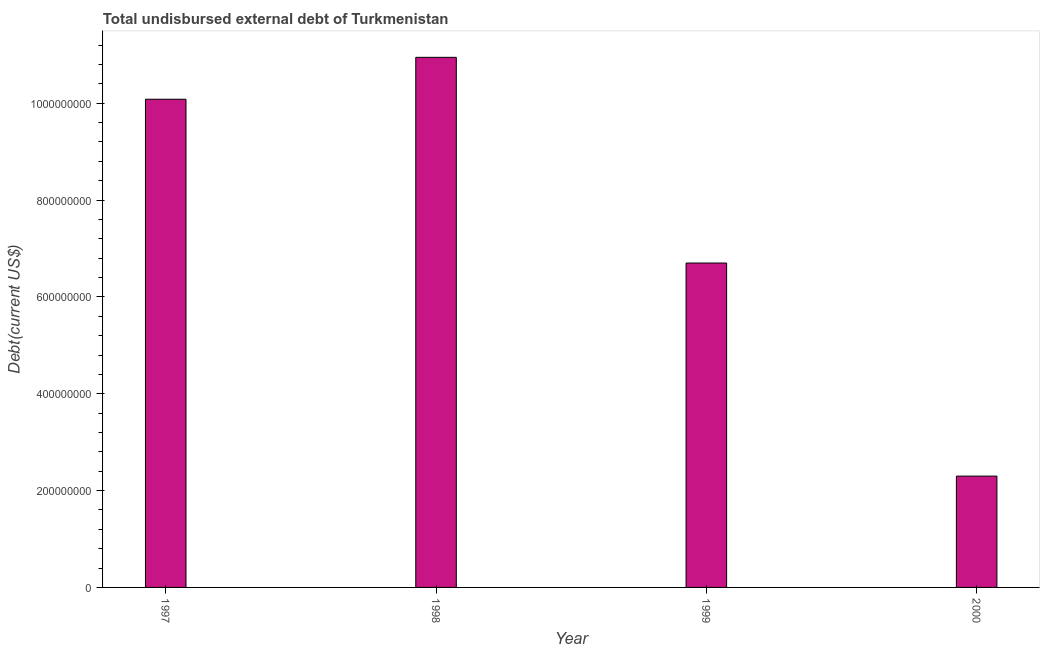What is the title of the graph?
Your response must be concise. Total undisbursed external debt of Turkmenistan. What is the label or title of the Y-axis?
Provide a short and direct response. Debt(current US$). What is the total debt in 1999?
Offer a very short reply. 6.70e+08. Across all years, what is the maximum total debt?
Provide a short and direct response. 1.09e+09. Across all years, what is the minimum total debt?
Make the answer very short. 2.30e+08. In which year was the total debt minimum?
Offer a terse response. 2000. What is the sum of the total debt?
Ensure brevity in your answer.  3.00e+09. What is the difference between the total debt in 1997 and 1999?
Provide a short and direct response. 3.38e+08. What is the average total debt per year?
Provide a short and direct response. 7.51e+08. What is the median total debt?
Your answer should be compact. 8.39e+08. In how many years, is the total debt greater than 680000000 US$?
Your response must be concise. 2. What is the ratio of the total debt in 1998 to that in 1999?
Provide a succinct answer. 1.63. Is the total debt in 1999 less than that in 2000?
Keep it short and to the point. No. Is the difference between the total debt in 1997 and 1998 greater than the difference between any two years?
Provide a short and direct response. No. What is the difference between the highest and the second highest total debt?
Ensure brevity in your answer.  8.66e+07. What is the difference between the highest and the lowest total debt?
Your response must be concise. 8.65e+08. In how many years, is the total debt greater than the average total debt taken over all years?
Offer a terse response. 2. How many bars are there?
Your answer should be very brief. 4. Are all the bars in the graph horizontal?
Keep it short and to the point. No. What is the difference between two consecutive major ticks on the Y-axis?
Give a very brief answer. 2.00e+08. What is the Debt(current US$) of 1997?
Keep it short and to the point. 1.01e+09. What is the Debt(current US$) of 1998?
Ensure brevity in your answer.  1.09e+09. What is the Debt(current US$) of 1999?
Offer a terse response. 6.70e+08. What is the Debt(current US$) in 2000?
Make the answer very short. 2.30e+08. What is the difference between the Debt(current US$) in 1997 and 1998?
Provide a short and direct response. -8.66e+07. What is the difference between the Debt(current US$) in 1997 and 1999?
Give a very brief answer. 3.38e+08. What is the difference between the Debt(current US$) in 1997 and 2000?
Your response must be concise. 7.78e+08. What is the difference between the Debt(current US$) in 1998 and 1999?
Offer a terse response. 4.25e+08. What is the difference between the Debt(current US$) in 1998 and 2000?
Make the answer very short. 8.65e+08. What is the difference between the Debt(current US$) in 1999 and 2000?
Give a very brief answer. 4.40e+08. What is the ratio of the Debt(current US$) in 1997 to that in 1998?
Your answer should be compact. 0.92. What is the ratio of the Debt(current US$) in 1997 to that in 1999?
Your answer should be compact. 1.5. What is the ratio of the Debt(current US$) in 1997 to that in 2000?
Offer a terse response. 4.38. What is the ratio of the Debt(current US$) in 1998 to that in 1999?
Provide a short and direct response. 1.63. What is the ratio of the Debt(current US$) in 1998 to that in 2000?
Provide a short and direct response. 4.76. What is the ratio of the Debt(current US$) in 1999 to that in 2000?
Your answer should be compact. 2.91. 